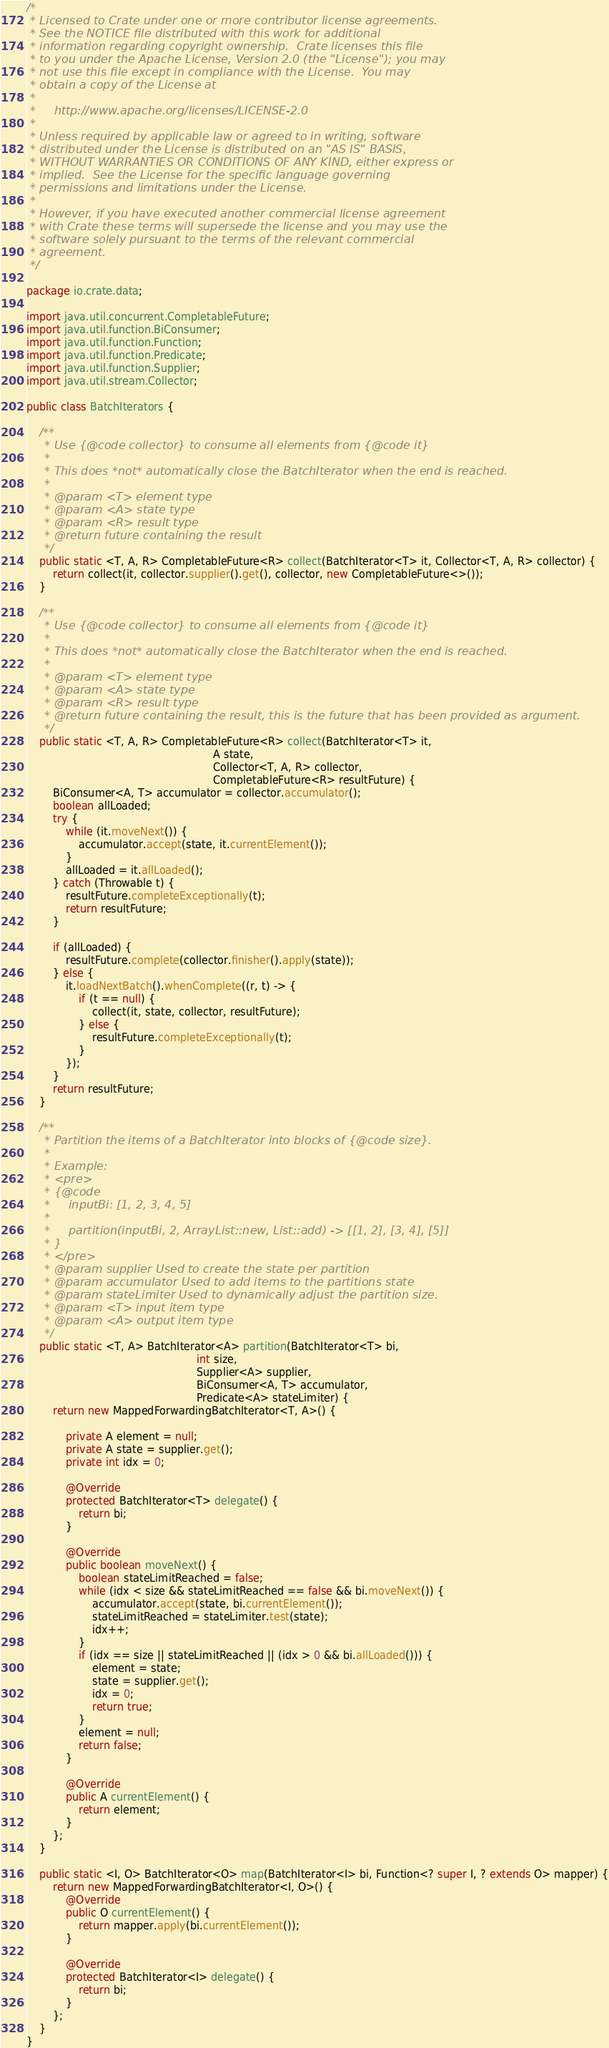Convert code to text. <code><loc_0><loc_0><loc_500><loc_500><_Java_>/*
 * Licensed to Crate under one or more contributor license agreements.
 * See the NOTICE file distributed with this work for additional
 * information regarding copyright ownership.  Crate licenses this file
 * to you under the Apache License, Version 2.0 (the "License"); you may
 * not use this file except in compliance with the License.  You may
 * obtain a copy of the License at
 *
 *     http://www.apache.org/licenses/LICENSE-2.0
 *
 * Unless required by applicable law or agreed to in writing, software
 * distributed under the License is distributed on an "AS IS" BASIS,
 * WITHOUT WARRANTIES OR CONDITIONS OF ANY KIND, either express or
 * implied.  See the License for the specific language governing
 * permissions and limitations under the License.
 *
 * However, if you have executed another commercial license agreement
 * with Crate these terms will supersede the license and you may use the
 * software solely pursuant to the terms of the relevant commercial
 * agreement.
 */

package io.crate.data;

import java.util.concurrent.CompletableFuture;
import java.util.function.BiConsumer;
import java.util.function.Function;
import java.util.function.Predicate;
import java.util.function.Supplier;
import java.util.stream.Collector;

public class BatchIterators {

    /**
     * Use {@code collector} to consume all elements from {@code it}
     *
     * This does *not* automatically close the BatchIterator when the end is reached.
     *
     * @param <T> element type
     * @param <A> state type
     * @param <R> result type
     * @return future containing the result
     */
    public static <T, A, R> CompletableFuture<R> collect(BatchIterator<T> it, Collector<T, A, R> collector) {
        return collect(it, collector.supplier().get(), collector, new CompletableFuture<>());
    }

    /**
     * Use {@code collector} to consume all elements from {@code it}
     *
     * This does *not* automatically close the BatchIterator when the end is reached.
     *
     * @param <T> element type
     * @param <A> state type
     * @param <R> result type
     * @return future containing the result, this is the future that has been provided as argument.
     */
    public static <T, A, R> CompletableFuture<R> collect(BatchIterator<T> it,
                                                         A state,
                                                         Collector<T, A, R> collector,
                                                         CompletableFuture<R> resultFuture) {
        BiConsumer<A, T> accumulator = collector.accumulator();
        boolean allLoaded;
        try {
            while (it.moveNext()) {
                accumulator.accept(state, it.currentElement());
            }
            allLoaded = it.allLoaded();
        } catch (Throwable t) {
            resultFuture.completeExceptionally(t);
            return resultFuture;
        }

        if (allLoaded) {
            resultFuture.complete(collector.finisher().apply(state));
        } else {
            it.loadNextBatch().whenComplete((r, t) -> {
                if (t == null) {
                    collect(it, state, collector, resultFuture);
                } else {
                    resultFuture.completeExceptionally(t);
                }
            });
        }
        return resultFuture;
    }

    /**
     * Partition the items of a BatchIterator into blocks of {@code size}.
     *
     * Example:
     * <pre>
     * {@code
     *     inputBi: [1, 2, 3, 4, 5]
     *
     *     partition(inputBi, 2, ArrayList::new, List::add) -> [[1, 2], [3, 4], [5]]
     * }
     * </pre>
     * @param supplier Used to create the state per partition
     * @param accumulator Used to add items to the partitions state
     * @param stateLimiter Used to dynamically adjust the partition size.
     * @param <T> input item type
     * @param <A> output item type
     */
    public static <T, A> BatchIterator<A> partition(BatchIterator<T> bi,
                                                    int size,
                                                    Supplier<A> supplier,
                                                    BiConsumer<A, T> accumulator,
                                                    Predicate<A> stateLimiter) {
        return new MappedForwardingBatchIterator<T, A>() {

            private A element = null;
            private A state = supplier.get();
            private int idx = 0;

            @Override
            protected BatchIterator<T> delegate() {
                return bi;
            }

            @Override
            public boolean moveNext() {
                boolean stateLimitReached = false;
                while (idx < size && stateLimitReached == false && bi.moveNext()) {
                    accumulator.accept(state, bi.currentElement());
                    stateLimitReached = stateLimiter.test(state);
                    idx++;
                }
                if (idx == size || stateLimitReached || (idx > 0 && bi.allLoaded())) {
                    element = state;
                    state = supplier.get();
                    idx = 0;
                    return true;
                }
                element = null;
                return false;
            }

            @Override
            public A currentElement() {
                return element;
            }
        };
    }

    public static <I, O> BatchIterator<O> map(BatchIterator<I> bi, Function<? super I, ? extends O> mapper) {
        return new MappedForwardingBatchIterator<I, O>() {
            @Override
            public O currentElement() {
                return mapper.apply(bi.currentElement());
            }

            @Override
            protected BatchIterator<I> delegate() {
                return bi;
            }
        };
    }
}
</code> 